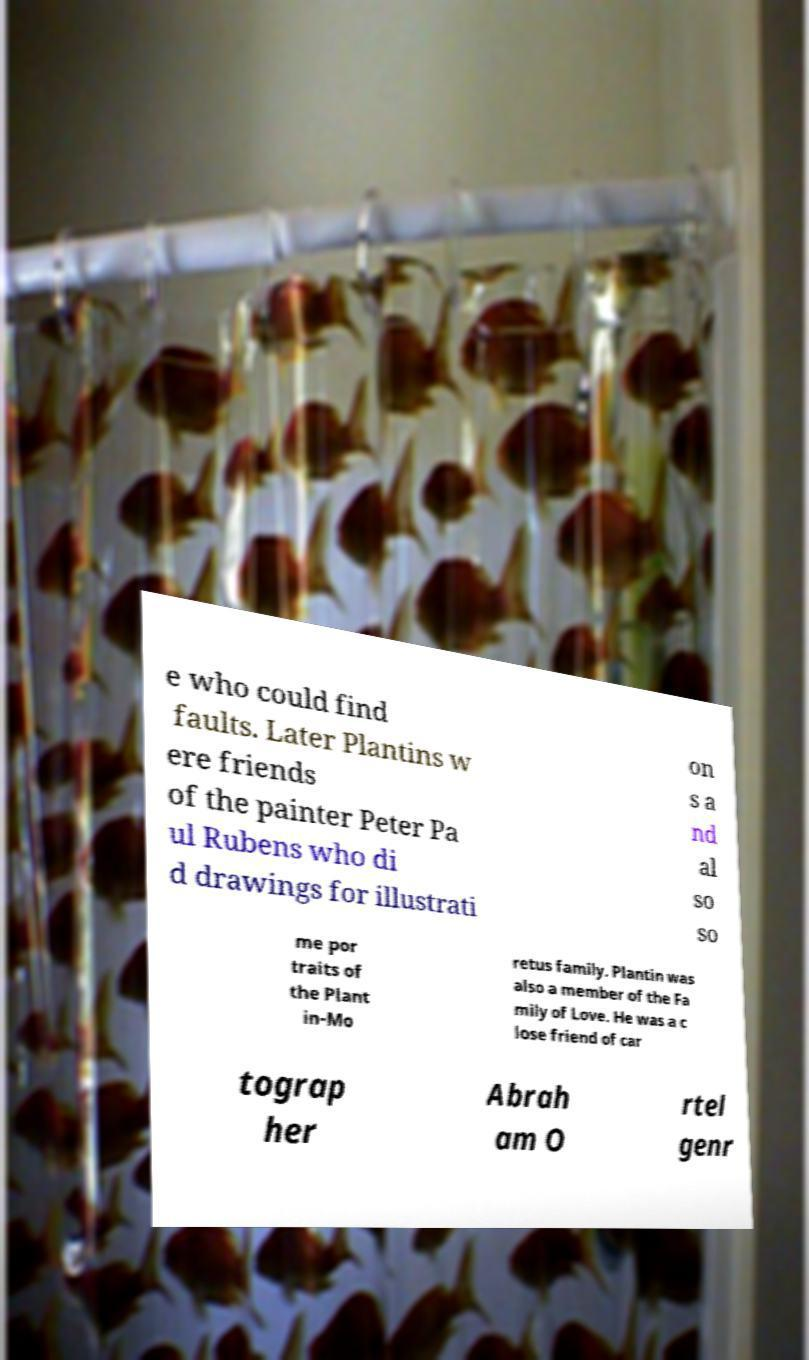Can you accurately transcribe the text from the provided image for me? e who could find faults. Later Plantins w ere friends of the painter Peter Pa ul Rubens who di d drawings for illustrati on s a nd al so so me por traits of the Plant in-Mo retus family. Plantin was also a member of the Fa mily of Love. He was a c lose friend of car tograp her Abrah am O rtel genr 